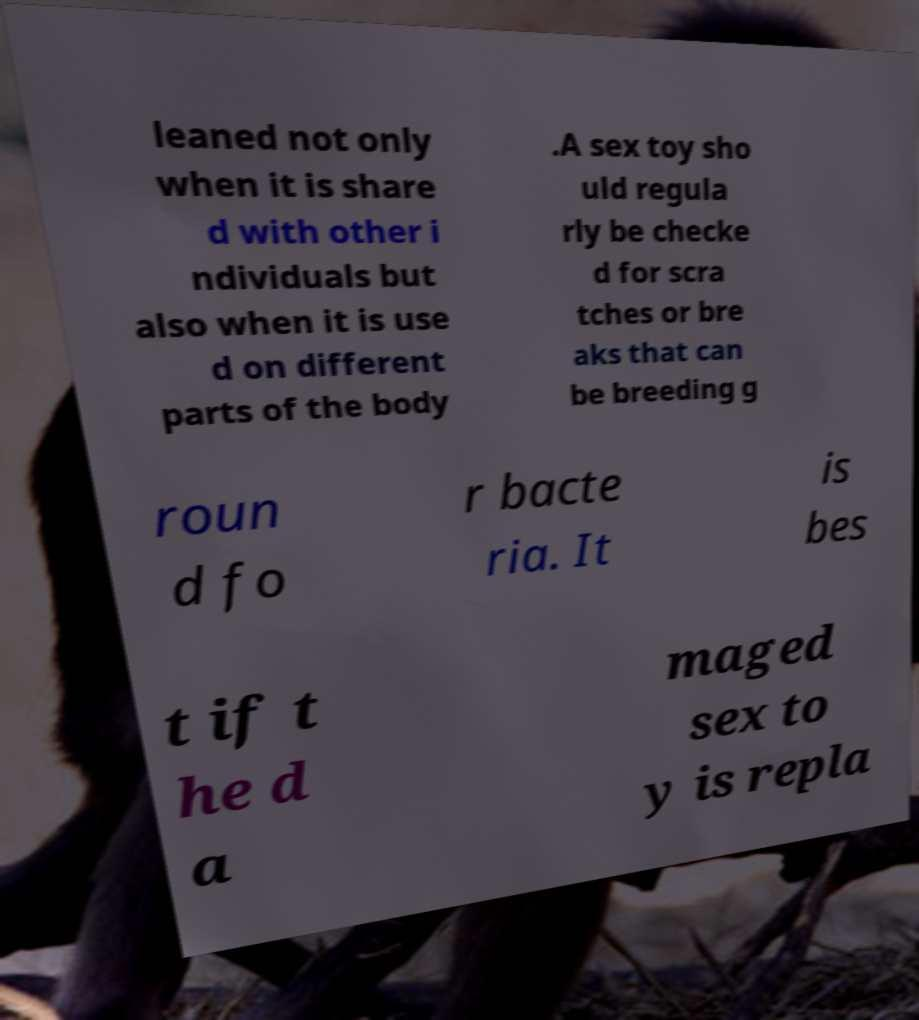Can you accurately transcribe the text from the provided image for me? leaned not only when it is share d with other i ndividuals but also when it is use d on different parts of the body .A sex toy sho uld regula rly be checke d for scra tches or bre aks that can be breeding g roun d fo r bacte ria. It is bes t if t he d a maged sex to y is repla 